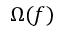<formula> <loc_0><loc_0><loc_500><loc_500>\Omega ( f )</formula> 